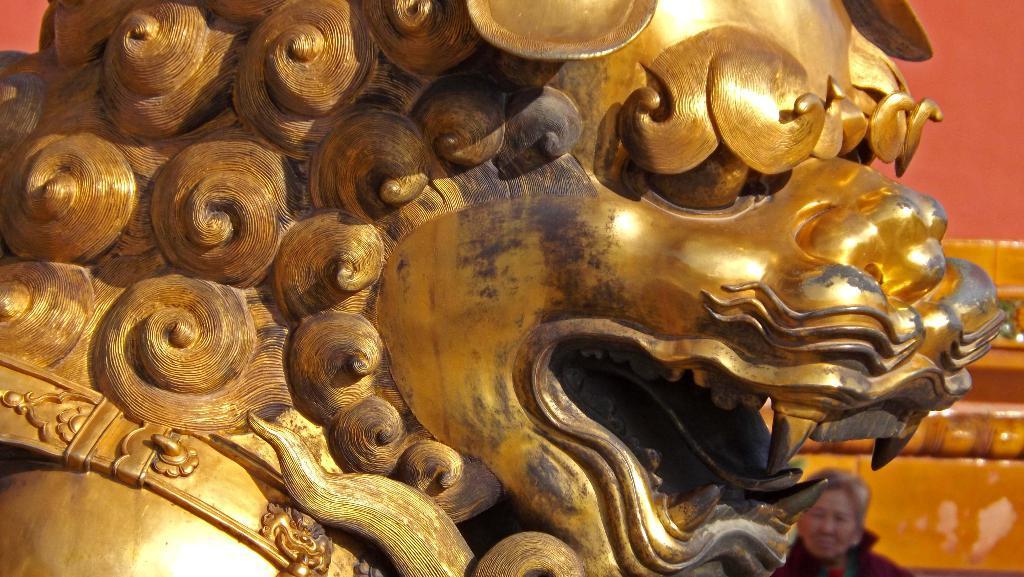In one or two sentences, can you explain what this image depicts? In this image we can see a sculpture and a woman, in the background it looks like the wall. 